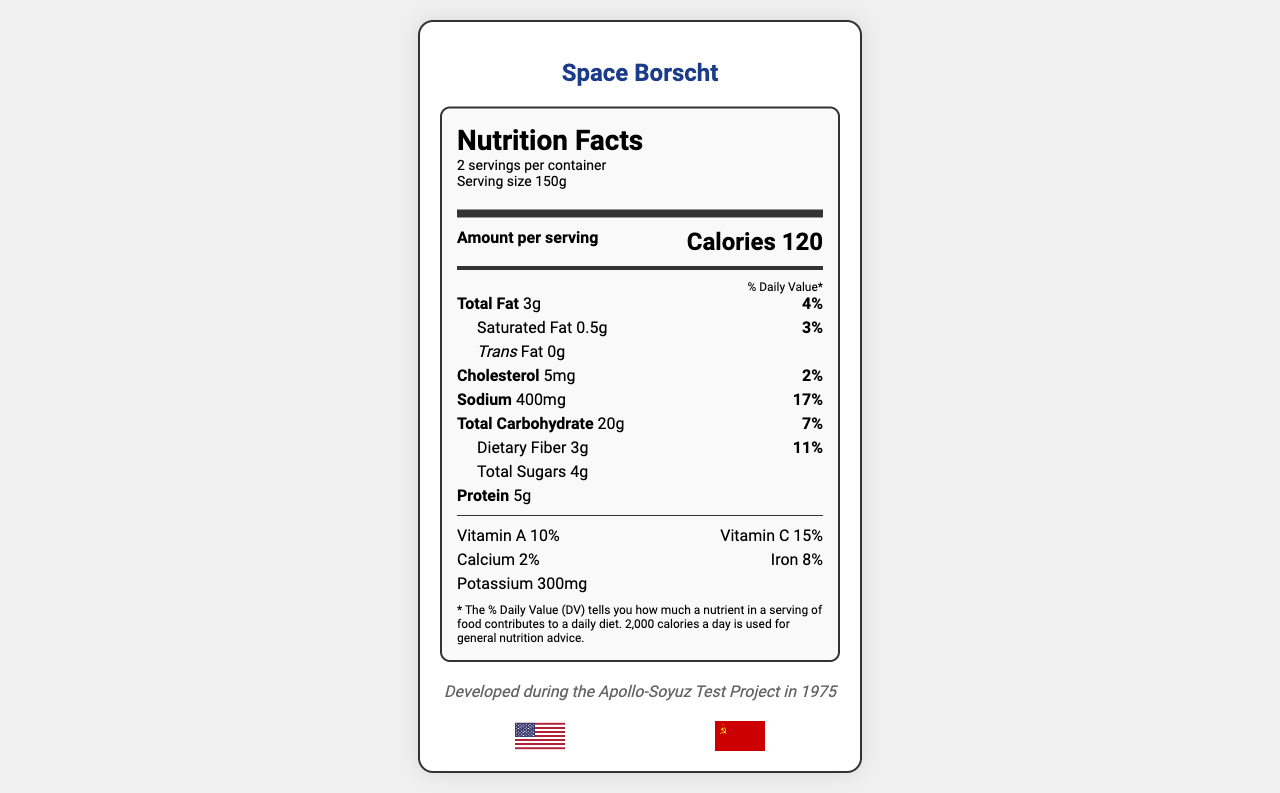what is the serving size? The serving size is mentioned at the top of the nutrition label under "Serving size 150g".
Answer: 150g how many servings are in the container? The label indicates that there are 2 servings per container.
Answer: 2 how many calories are in one serving? The label shows the number of calories per serving as 120.
Answer: 120 what is the total amount of sodium in the entire container? Each serving contains 400mg of sodium, and there are 2 servings per container: 400mg x 2 = 800mg.
Answer: 800mg how much dietary fiber is in one serving? The nutrition label indicates 3g of dietary fiber per serving.
Answer: 3g how many grams of total fat are in one serving? The nutrition label lists total fat as 3g per serving.
Answer: 3g how many grams of protein are in one serving? The label indicates there are 5 grams of protein per serving.
Answer: 5g what percentage of the daily value of vitamin C is in one serving? The label states that one serving contains 15% of the daily value of vitamin C.
Answer: 15% what is the historical significance of this product? The document mentions this product was developed during the Apollo-Soyuz Test Project in 1975.
Answer: Developed during the Apollo-Soyuz Test Project in 1975 who formulated this space food? The label indicates that the food was formulated by NASA and the Soviet Institute of Biomedical Problems.
Answer: NASA and Soviet Institute of Biomedical Problems What is the caloric content per serving? A. 100 B. 150 C. 120 D. 200 The label shows that each serving has 120 calories.
Answer: C How much potassium is in one serving? A. 300mg B. 200mg C. 150mg D. 250mg The label states that one serving contains 300mg of potassium.
Answer: A What is the main purpose of this document? The document's main purpose is to offer comprehensive nutritional information and historical context about the Space Borscht.
Answer: To provide nutritional information about Space Borscht used in joint US-Soviet space missions Is this product designed to meet the dietary requirements of astronauts and cosmonauts? The label mentions that the product is a balanced meal designed to meet astronaut and cosmonaut dietary requirements.
Answer: Yes How is the product's extended shelf life achieved? While the document mentions a freeze-drying process to preserve nutrients, it does not detail the complete process to extend shelf life.
Answer: Not enough information 